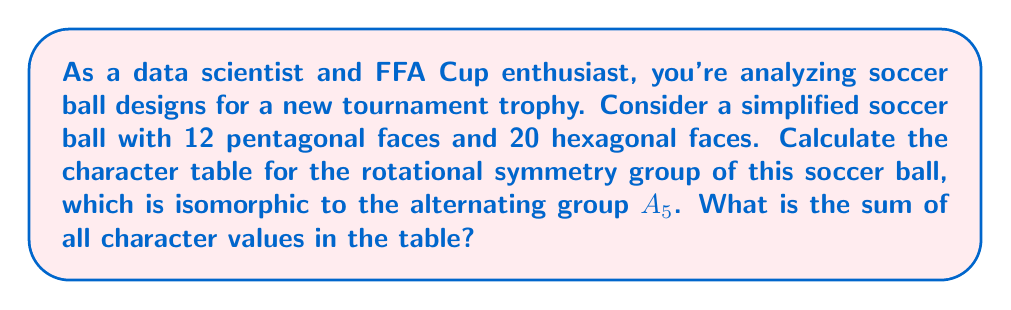Solve this math problem. Let's approach this step-by-step:

1) The rotational symmetry group of a soccer ball (truncated icosahedron) is isomorphic to $A_5$, the alternating group on 5 elements.

2) $A_5$ has 5 conjugacy classes:
   - $[1]$: identity
   - $[12]$: 15 elements of order 2
   - $[3]$: 20 elements of order 3
   - $[5]$: 12 elements of order 5
   - $[5']$: 12 elements of order 5 (rotations in the opposite direction)

3) The character table for $A_5$ is:

   $$\begin{array}{c|ccccc}
      & [1] & [12] & [3] & [5] & [5'] \\
   \hline
   \chi_1 & 1 & 1 & 1 & 1 & 1 \\
   \chi_2 & 3 & -1 & 0 & \frac{1+\sqrt{5}}{2} & \frac{1-\sqrt{5}}{2} \\
   \chi_3 & 3 & -1 & 0 & \frac{1-\sqrt{5}}{2} & \frac{1+\sqrt{5}}{2} \\
   \chi_4 & 4 & 0 & 1 & -1 & -1 \\
   \chi_5 & 5 & 1 & -1 & 0 & 0
   \end{array}$$

4) To find the sum of all character values, we add up all entries in the table:

   $S = (1+1+1+1+1) + (3-1+0+\frac{1+\sqrt{5}}{2}+\frac{1-\sqrt{5}}{2}) + (3-1+0+\frac{1-\sqrt{5}}{2}+\frac{1+\sqrt{5}}{2}) + (4+0+1-1-1) + (5+1-1+0+0)$

5) Simplifying:
   $S = 5 + 3 + 3 + 3 + 5 = 19$

Therefore, the sum of all character values in the table is 19.
Answer: 19 